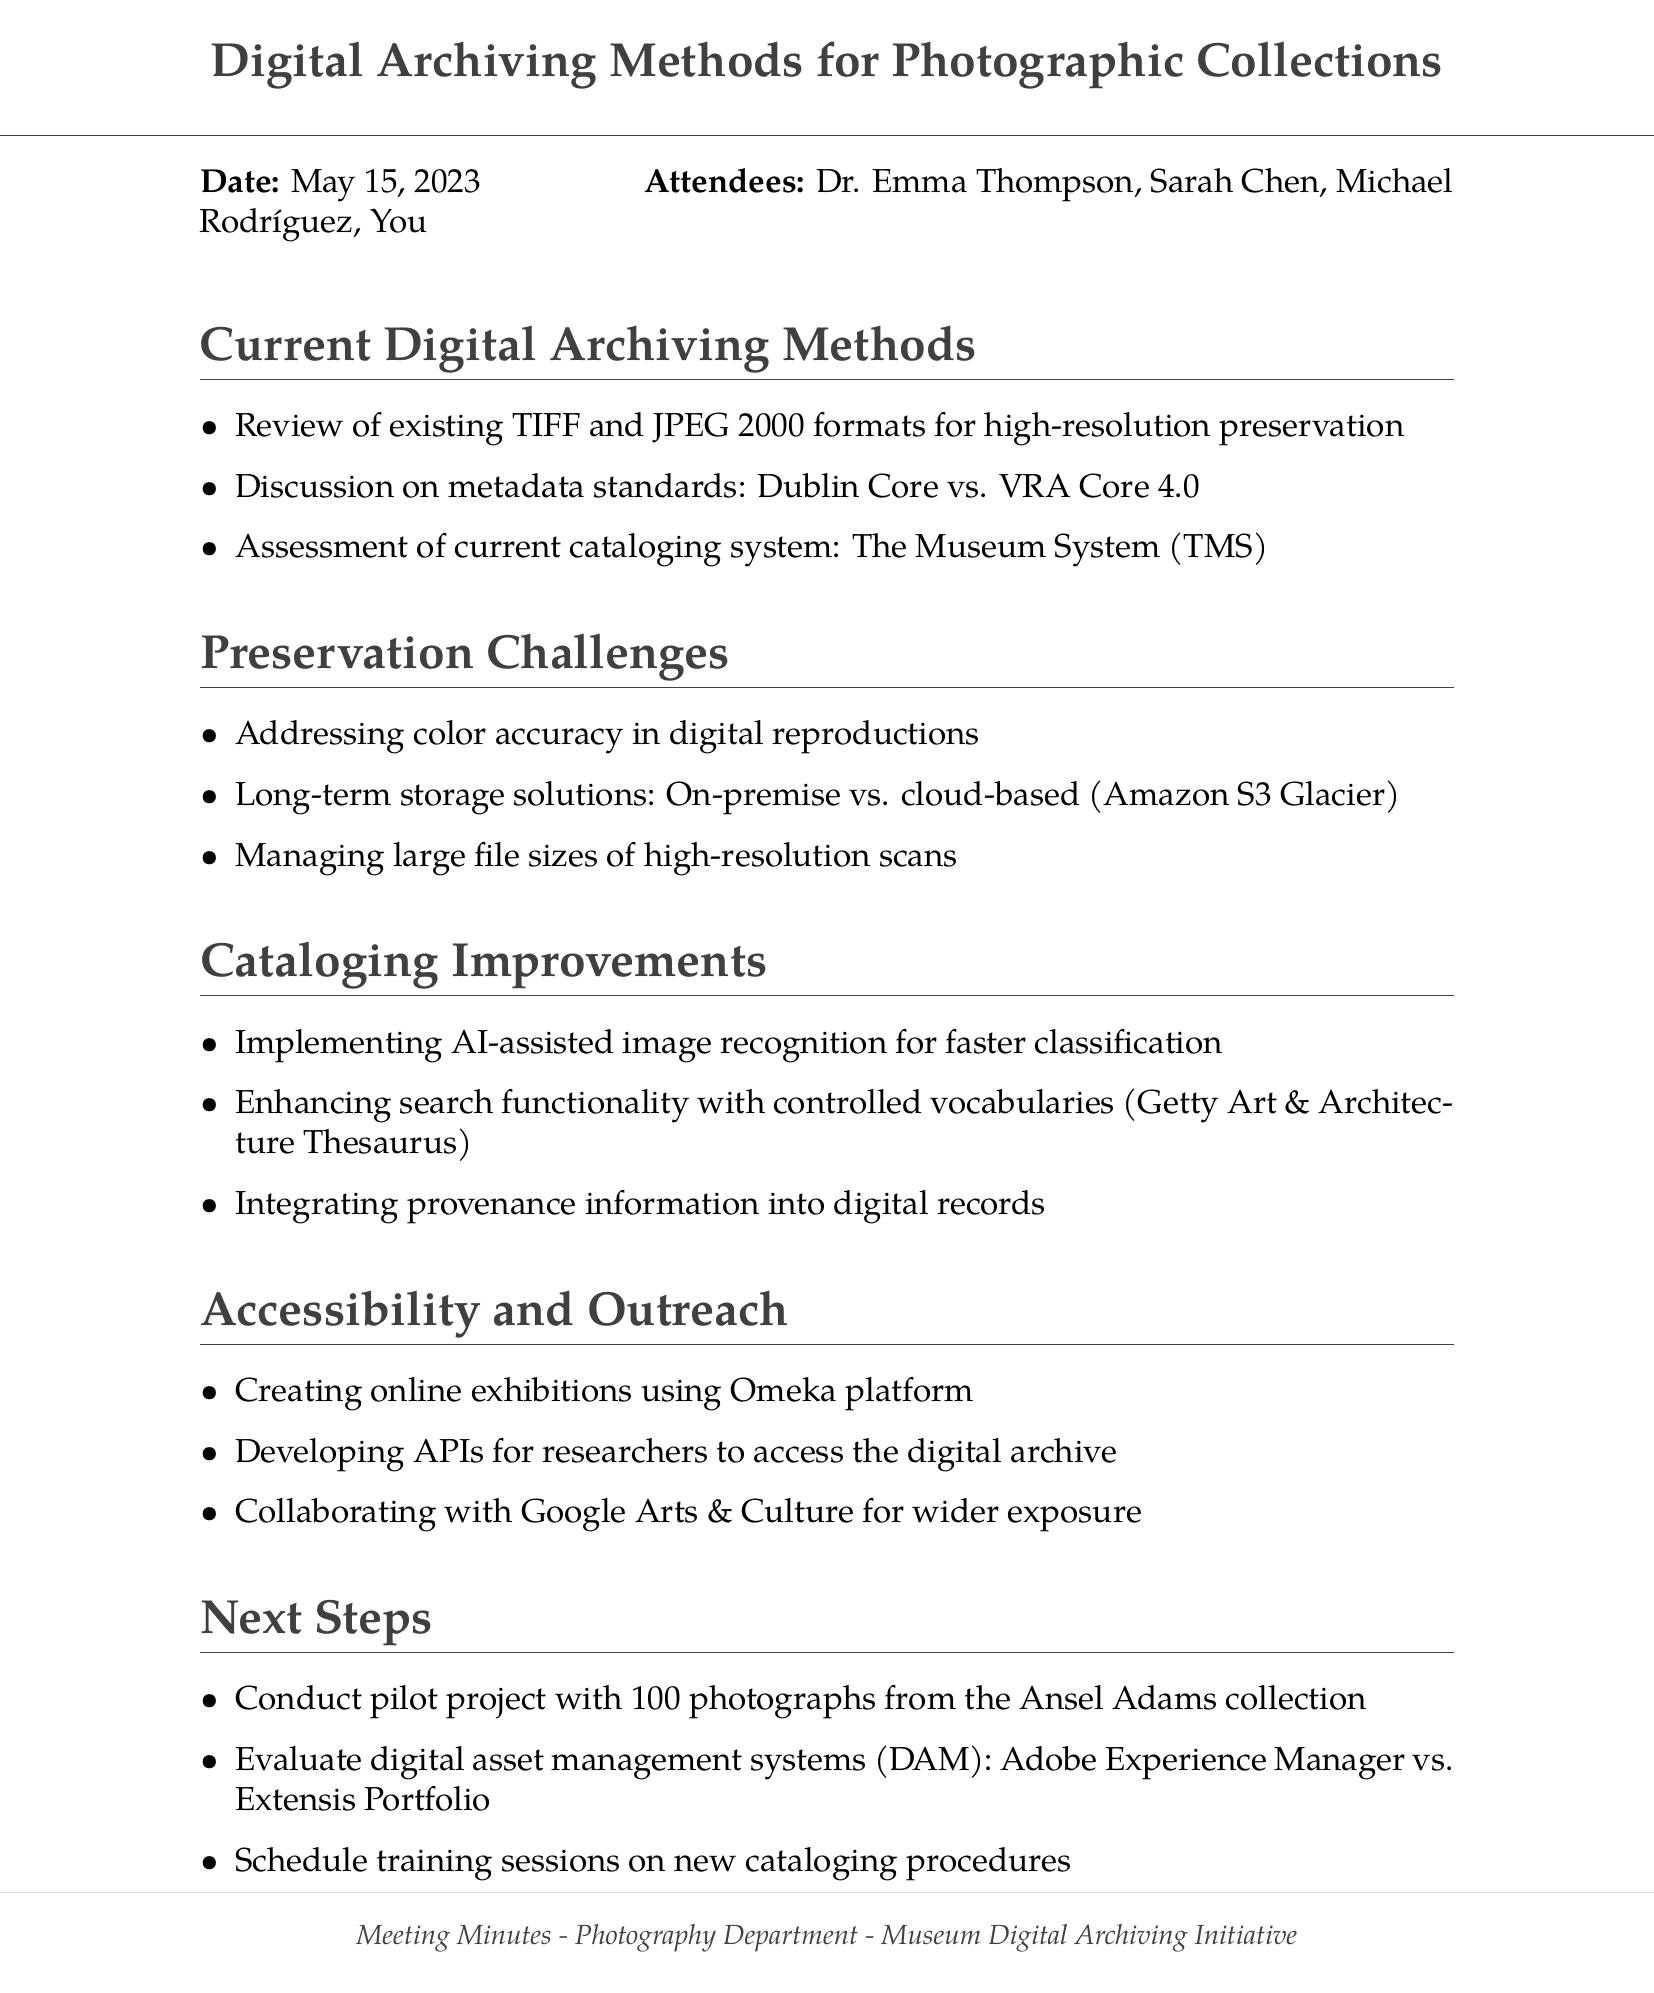what is the meeting title? The meeting title is provided at the start of the document.
Answer: Digital Archiving Methods for Photographic Collections who is the head curator? The document lists attendees, including their roles and names.
Answer: Dr. Emma Thompson what is the date of the meeting? The meeting date is stated prominently in the document.
Answer: May 15, 2023 what format is discussed for high-resolution preservation? The agenda item lists specific formats being reviewed for preservation.
Answer: TIFF and JPEG 2000 what cloud service is mentioned for long-term storage solutions? The document specifies a cloud service option under preservation challenges.
Answer: Amazon S3 Glacier how many photographs will be included in the pilot project? The next steps section indicates the number of photographs for the project.
Answer: 100 which platform is suggested for creating online exhibitions? The accessibility and outreach section suggests a platform for exhibitions.
Answer: Omeka what are the two digital asset management systems evaluated? The next steps section lists two systems for evaluation.
Answer: Adobe Experience Manager vs. Extensis Portfolio which thesaurus is mentioned for enhancing search functionality? The cataloging improvements section refers to a specific thesaurus.
Answer: Getty Art & Architecture Thesaurus 